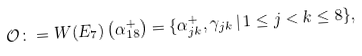<formula> <loc_0><loc_0><loc_500><loc_500>\mathcal { O } \colon = W ( E _ { 7 } ) \left ( \alpha _ { 1 8 } ^ { + } \right ) = \{ \alpha _ { j k } ^ { + } , \gamma _ { j k } \, | \, 1 \leq j < k \leq 8 \} ,</formula> 